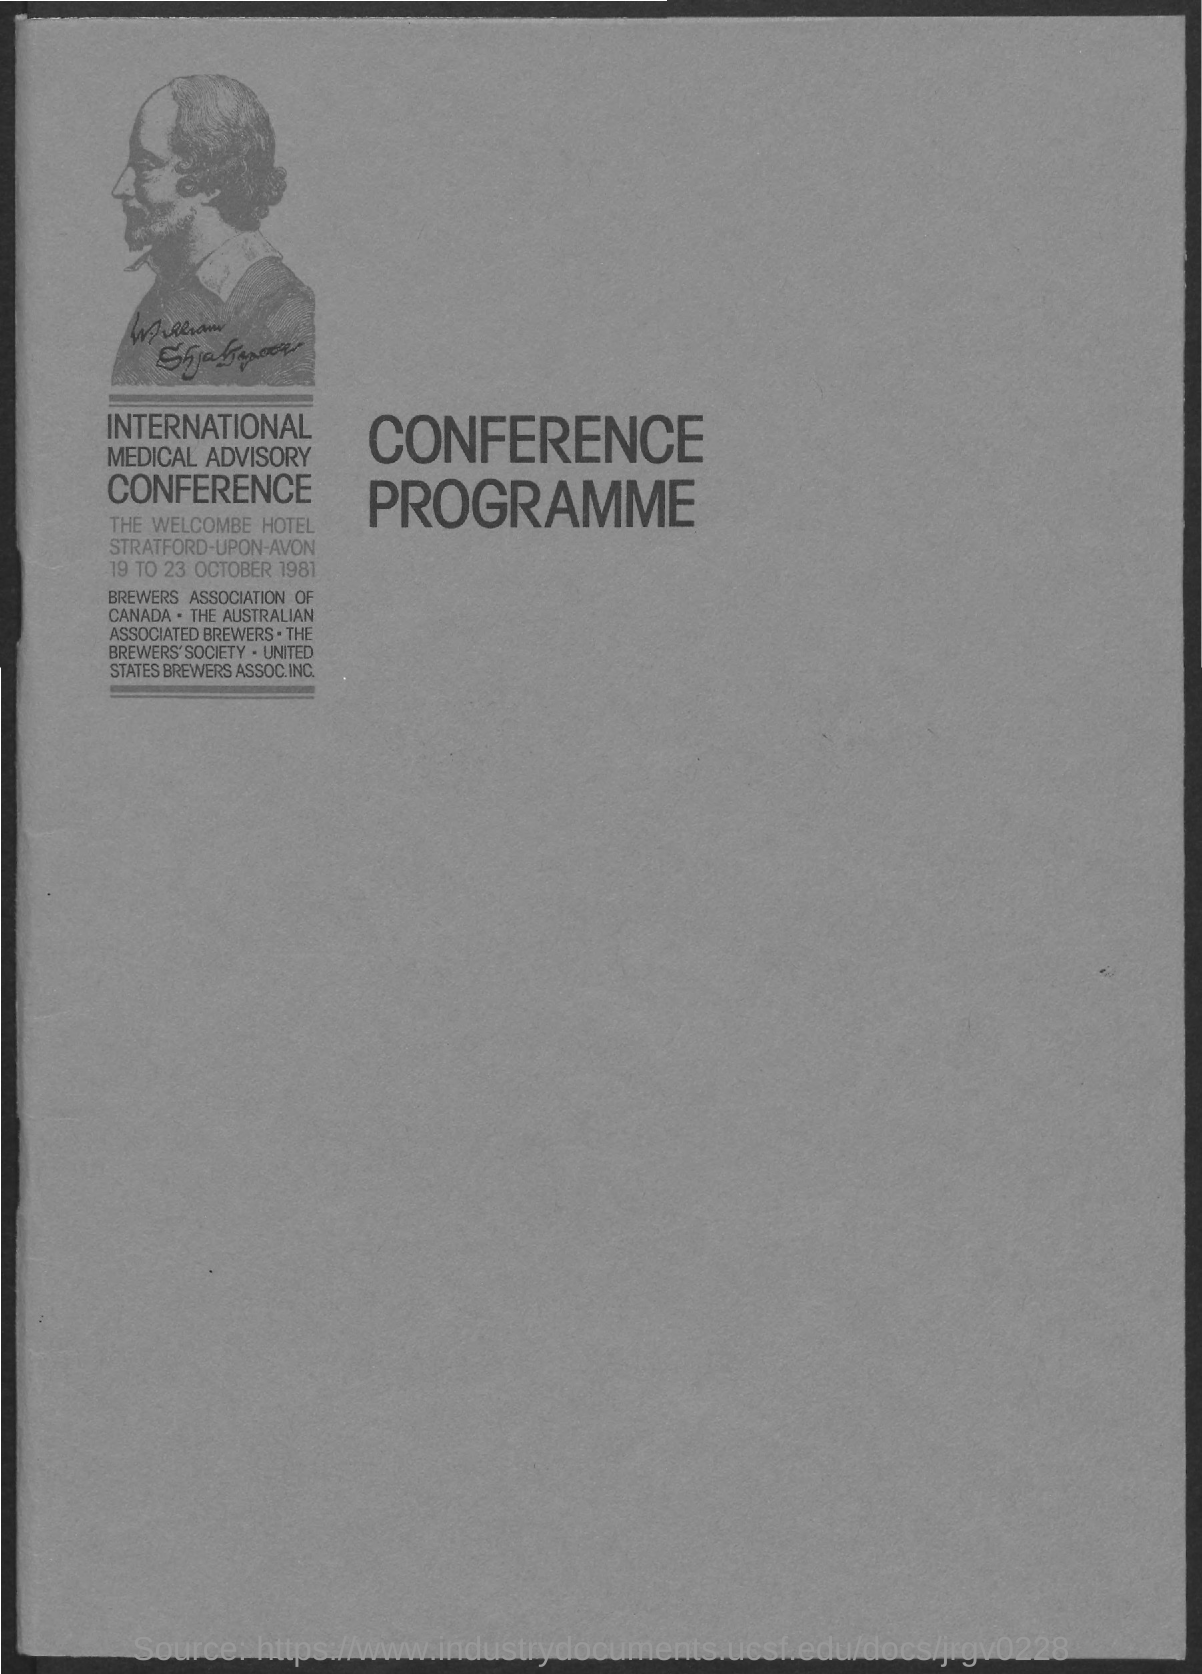When is the International Medical Advisory Conference held?
Give a very brief answer. 19 TO 23 OCTOBER 1981. 